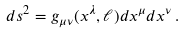Convert formula to latex. <formula><loc_0><loc_0><loc_500><loc_500>d s ^ { 2 } = g _ { \mu \nu } ( x ^ { \lambda } , \ell ) d x ^ { \mu } d x ^ { \nu } \, .</formula> 